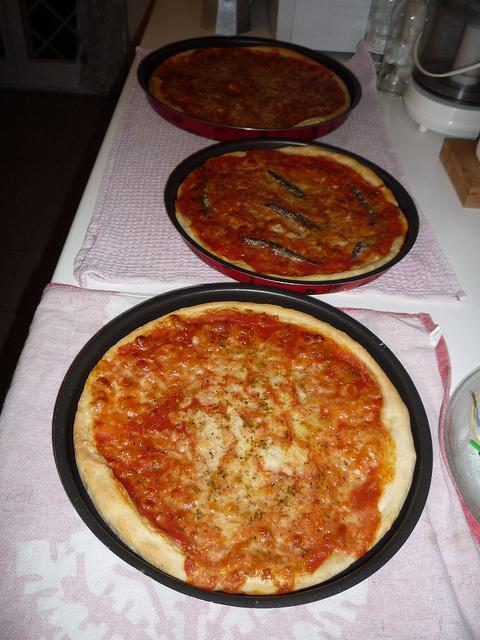What is the largest pizza on top of? Please explain your reasoning. tray. Pizza is served on a flat round pan. 